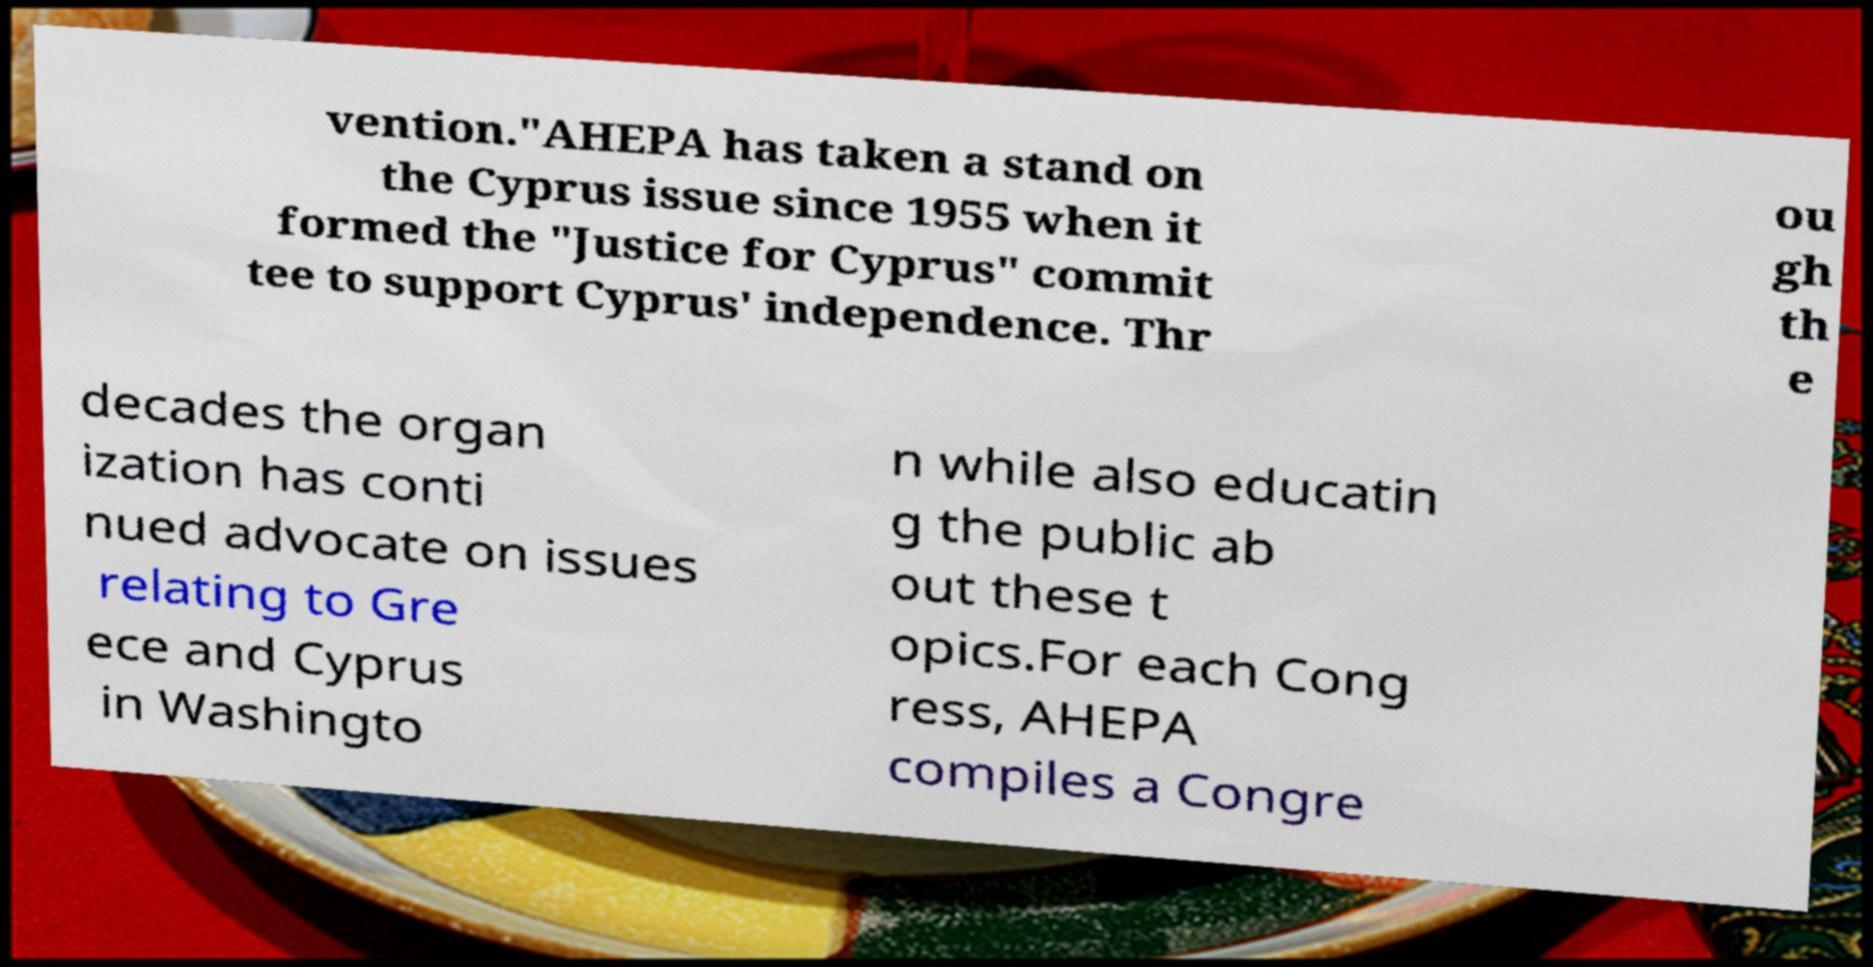Could you assist in decoding the text presented in this image and type it out clearly? vention."AHEPA has taken a stand on the Cyprus issue since 1955 when it formed the "Justice for Cyprus" commit tee to support Cyprus' independence. Thr ou gh th e decades the organ ization has conti nued advocate on issues relating to Gre ece and Cyprus in Washingto n while also educatin g the public ab out these t opics.For each Cong ress, AHEPA compiles a Congre 